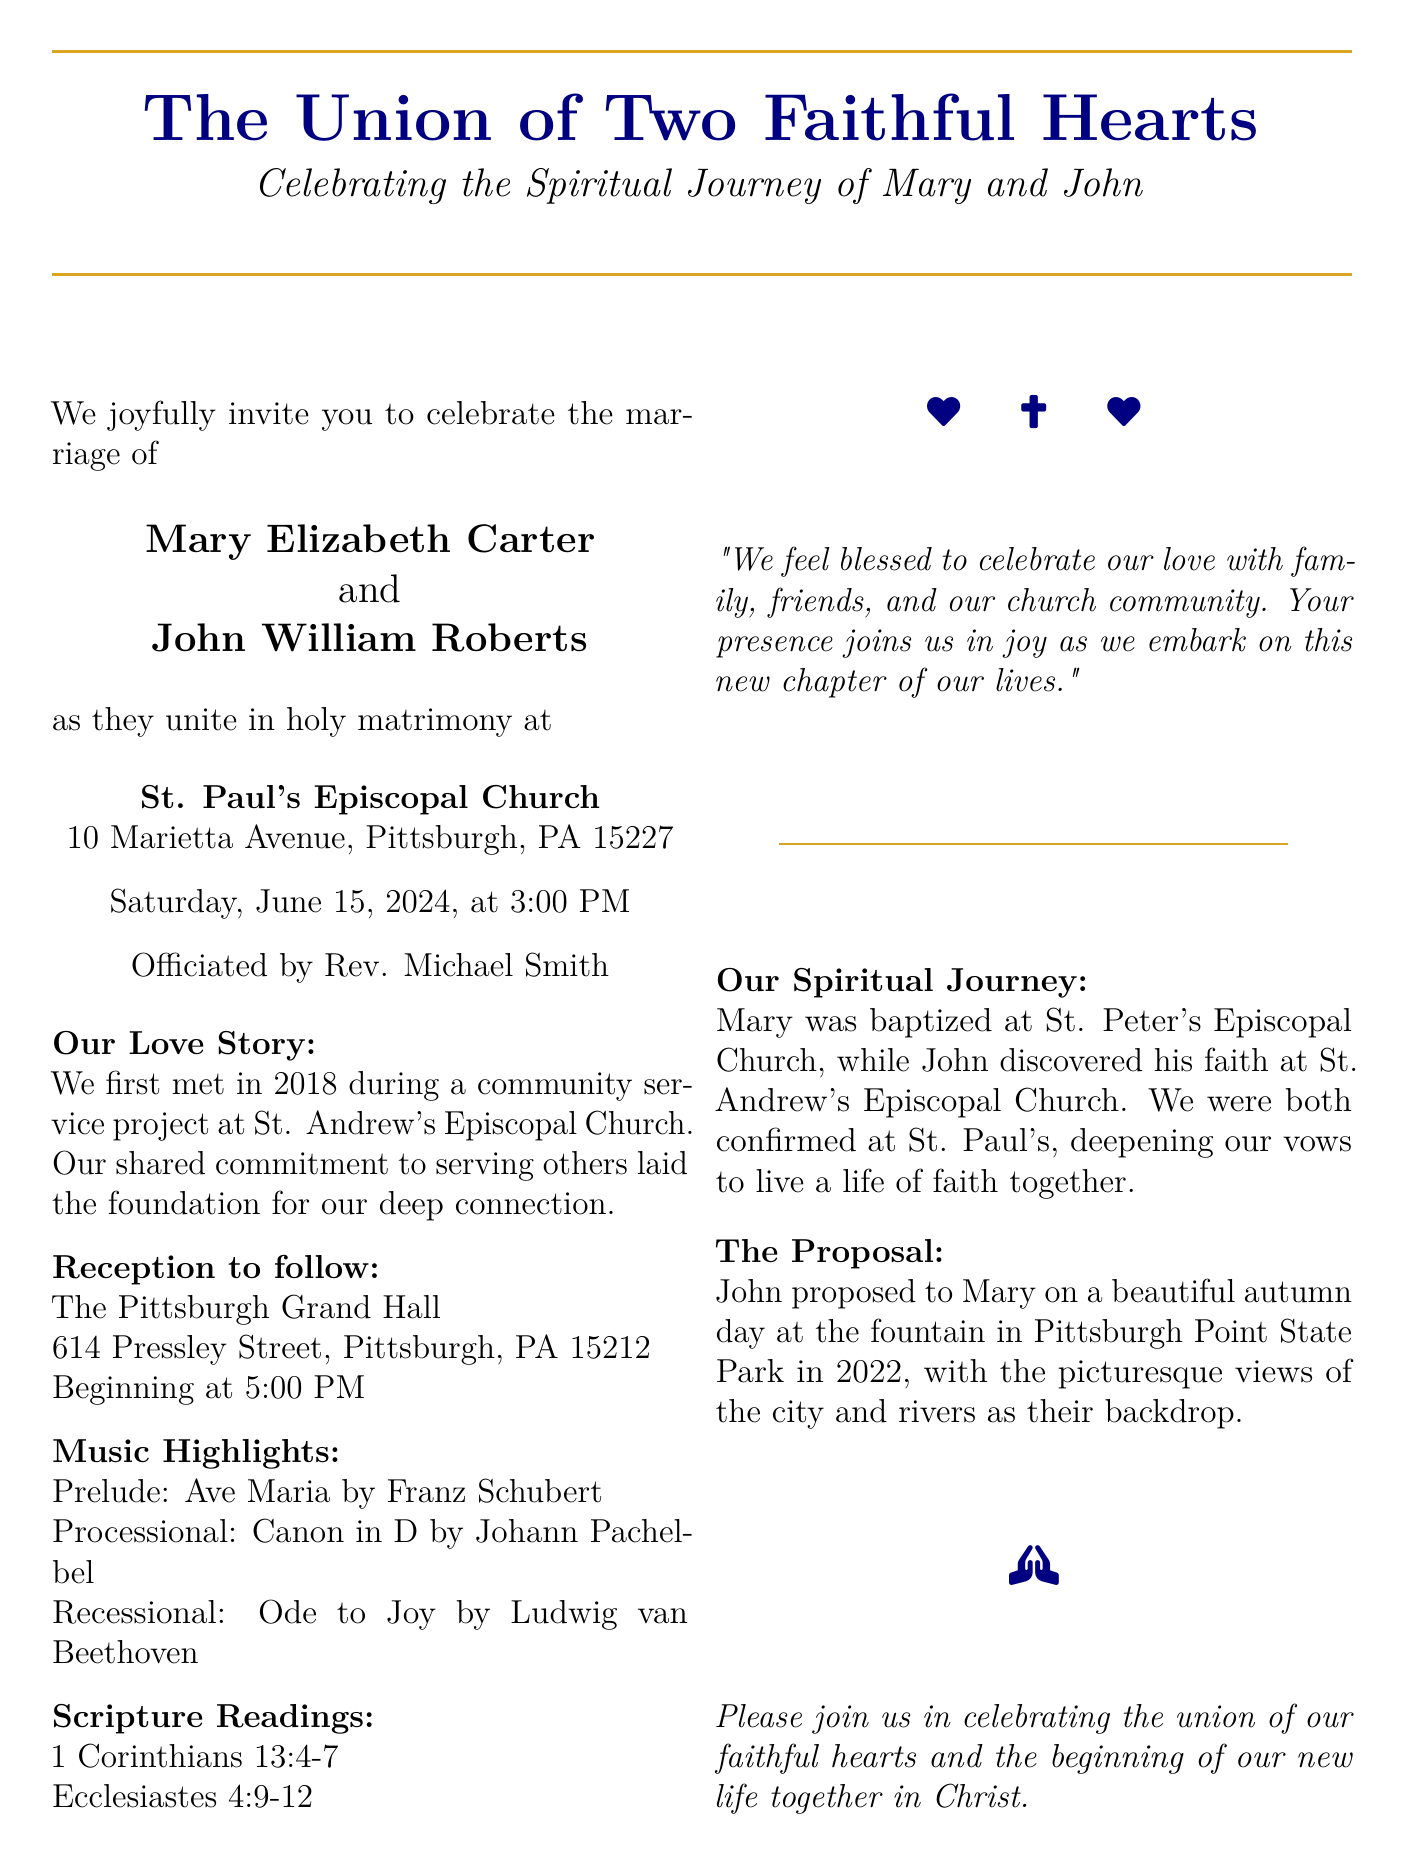What are the names of the couple? The document clearly states the names of the couple getting married.
Answer: Mary Elizabeth Carter and John William Roberts When is the wedding date? The wedding date is explicitly mentioned in the document.
Answer: Saturday, June 15, 2024 Where is the ceremony taking place? The invitation specifies the location of the wedding ceremony.
Answer: St. Paul's Episcopal Church Who is officiating the wedding? The document lists the name of the officiant for the ceremony.
Answer: Rev. Michael Smith What highlight event follows the wedding ceremony? The document indicates that a specific event occurs after the ceremony.
Answer: Reception What are the scripture readings included? The document lists the specific scripture readings that will be included in the ceremony.
Answer: 1 Corinthians 13:4-7, Ecclesiastes 4:9-12 What was a significant event in their love story? The document shares details about when and where the couple first met.
Answer: Community service project at St. Andrew's Episcopal Church At what time does the reception begin? The time for the reception is clearly stated in the document.
Answer: 5:00 PM What was the location of the proposal? The document describes where John proposed to Mary.
Answer: Pittsburgh Point State Park 